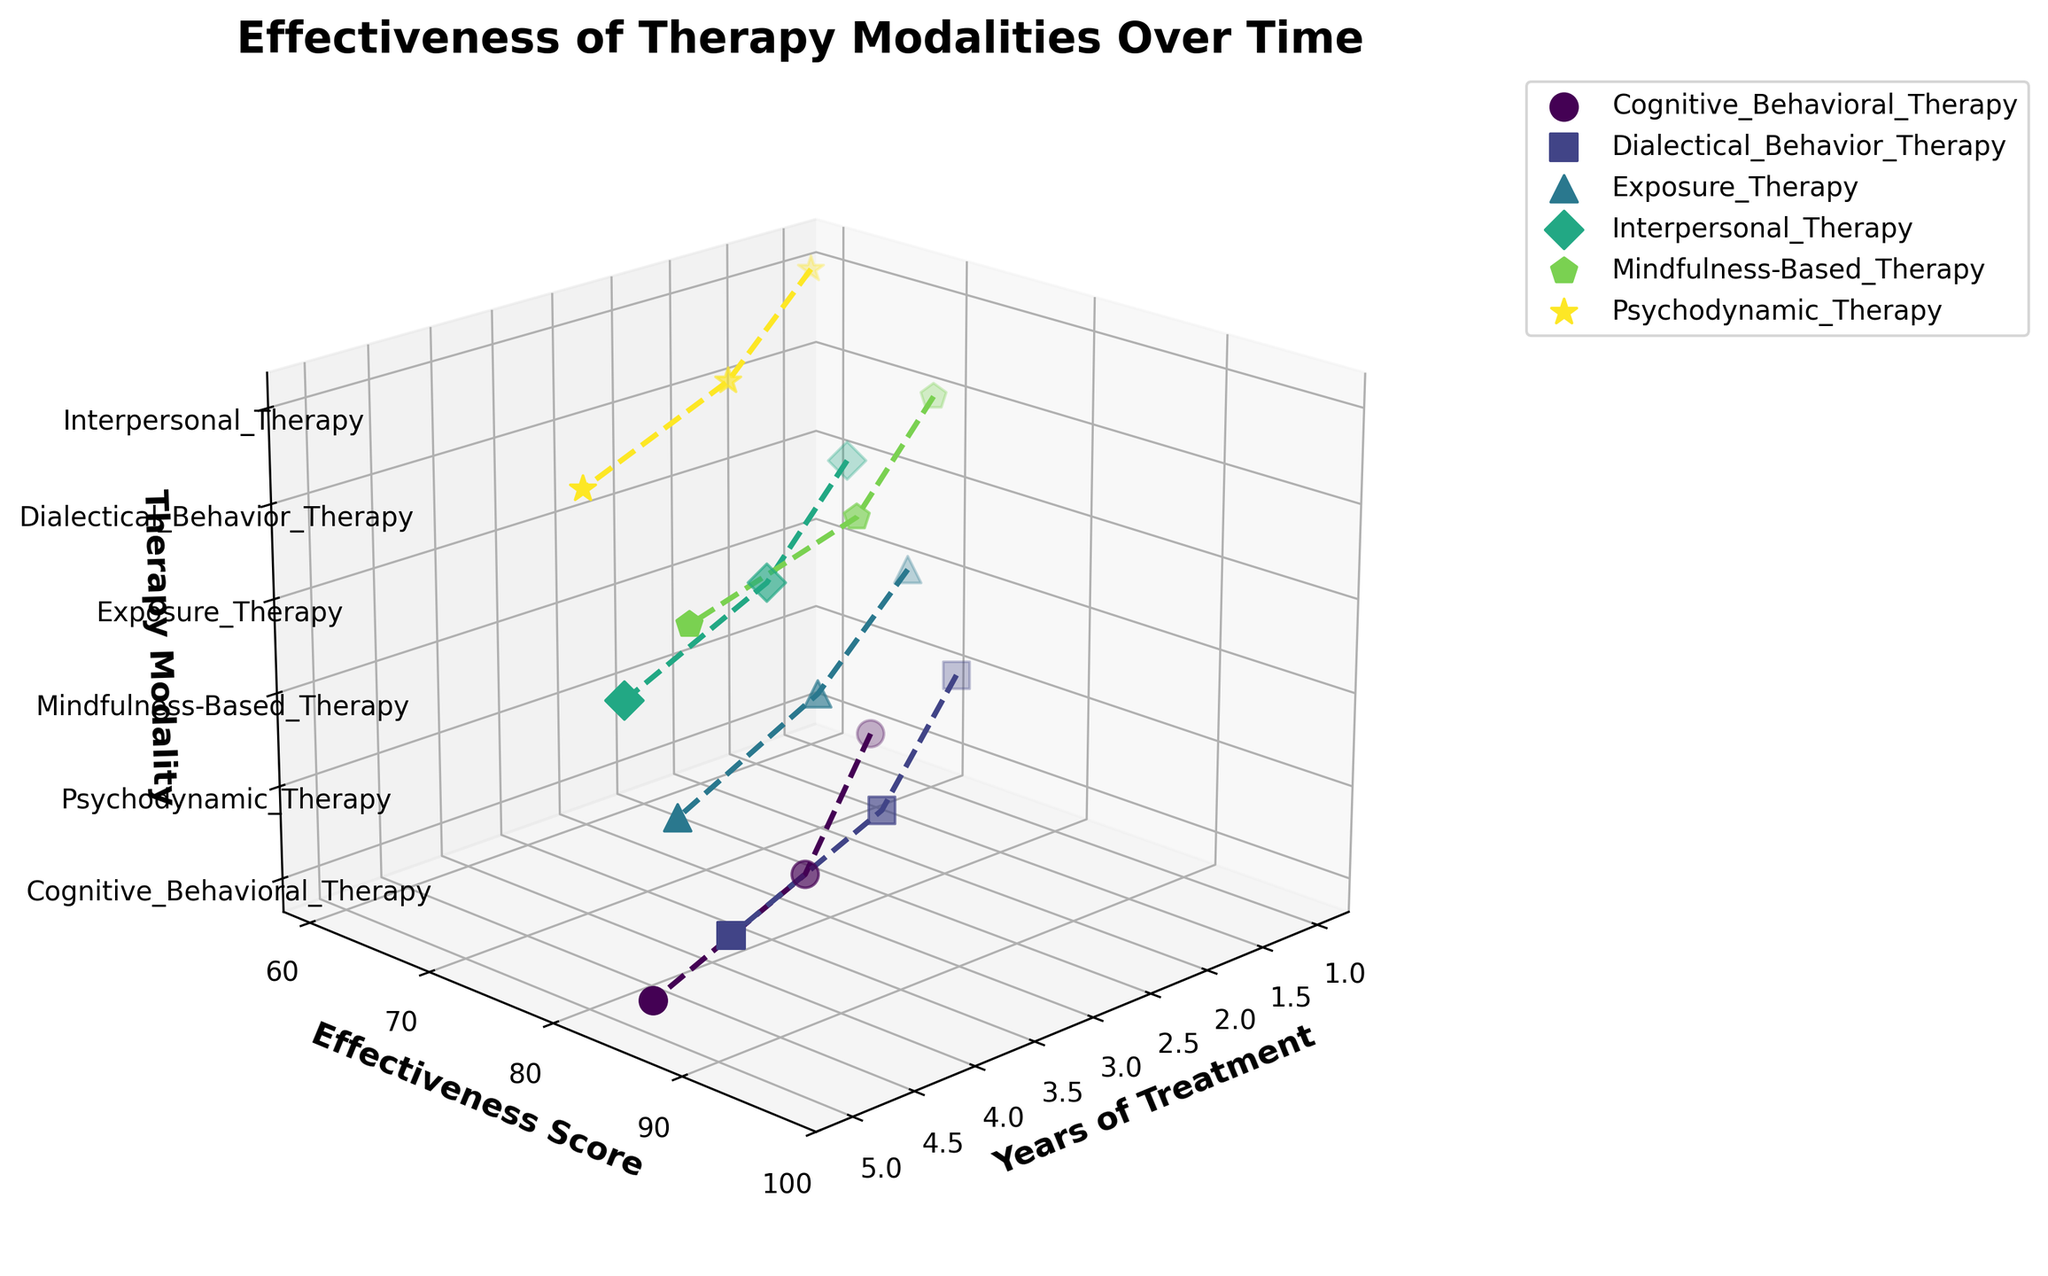what is the title of the figure? The title is displayed at the top of the figure, providing a clear description of what the plot represents. In this case, the title is "Effectiveness of Therapy Modalities Over Time".
Answer: Effectiveness of Therapy Modalities Over Time How many therapy modalities are displayed in the 3D plot? The number of therapy modalities can be identified by counting the unique categories along the z-axis of the plot. Each unique therapy modality corresponds to a different category on the z-axis.
Answer: 6 Which therapy modality shows the highest effectiveness score after 5 years of treatment? By locating the data points for 5 years of treatment along the x-axis and identifying the corresponding maximum effectiveness score along the y-axis, we see that the highest score belongs to Dialectical Behavior Therapy.
Answer: Dialectical Behavior Therapy How does the effectiveness score of Psychodynamic Therapy for depression change over time? By following the plot line for Psychodynamic Therapy (Depression) along the x-axis (Years of Treatment) and checking the corresponding y-axis (Effectiveness Score) values, we can observe an increase over time: 60 at 1 year, 72 at 3 years, and 80 at 5 years.
Answer: It increases from 60 to 72 to 80 Which mental health condition shows the highest initial effectiveness score at year 1? To determine this, we need to compare the effectiveness scores at year 1 for all mental health conditions. The highest initial effectiveness score at year 1 is for Dialectical Behavior Therapy treating Borderline Personality Disorder with a score of 72.
Answer: Borderline Personality Disorder Do all therapy modalities show an increase in effectiveness over the 5 years? By examining each therapy modality's data points and their trends from year 1 to year 5, we observe that all therapy modalities show an upward trend in effectiveness scores over time.
Answer: Yes Which therapy modality shows the fastest increase in effectiveness for its mental health condition, as seen by the steepest slope in the 3D plot? The steepness of the slope in the 3D plot indicates how quickly the effectiveness score increases over time. Dialectical Behavior Therapy for Borderline Personality Disorder appears to have the steepest slope, indicating the fastest increase.
Answer: Dialectical Behavior Therapy What is the effectiveness score of Exposure Therapy for PTSD after 3 years of treatment? By locating the data point for Exposure Therapy treating PTSD at 3 years on the x-axis and checking the corresponding effectiveness score on the y-axis, we find a score of 79.
Answer: 79 Compare the effectiveness scores of Mindfulness-Based Therapy for Anxiety and Cognitive Behavioral Therapy for Depression after 5 years of treatment. By checking the data points for both therapies at year 5 along the x-axis, we find that Mindfulness-Based Therapy for Anxiety has a score of 88, and Cognitive Behavioral Therapy for Depression has a score of 85.
Answer: Mindfulness-Based Therapy: 88, Cognitive Behavioral Therapy: 85 